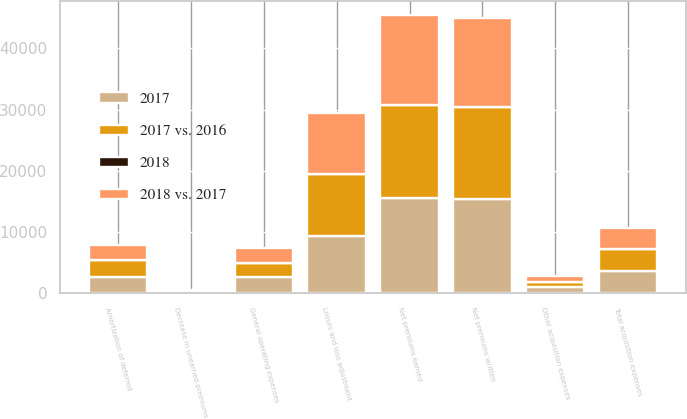<chart> <loc_0><loc_0><loc_500><loc_500><stacked_bar_chart><ecel><fcel>Net premiums written<fcel>Decrease in unearned premiums<fcel>Net premiums earned<fcel>Losses and loss adjustment<fcel>Amortization of deferred<fcel>Other acquisition expenses<fcel>Total acquisition expenses<fcel>General operating expenses<nl><fcel>2017 vs. 2016<fcel>15024<fcel>167<fcel>15191<fcel>10048<fcel>2737<fcel>870<fcel>3607<fcel>2360<nl><fcel>2018 vs. 2017<fcel>14465<fcel>106<fcel>14571<fcel>9996<fcel>2460<fcel>903<fcel>3363<fcel>2316<nl><fcel>2017<fcel>15367<fcel>255<fcel>15622<fcel>9411<fcel>2677<fcel>1014<fcel>3691<fcel>2685<nl><fcel>2018<fcel>4<fcel>58<fcel>4<fcel>1<fcel>11<fcel>4<fcel>7<fcel>2<nl></chart> 